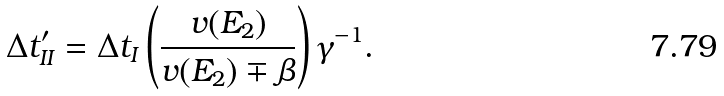Convert formula to latex. <formula><loc_0><loc_0><loc_500><loc_500>\Delta t _ { I I } ^ { \prime } = \Delta t _ { I } \left ( \frac { v ( E _ { 2 } ) } { v ( E _ { 2 } ) \mp \beta } \right ) \gamma ^ { - 1 } .</formula> 